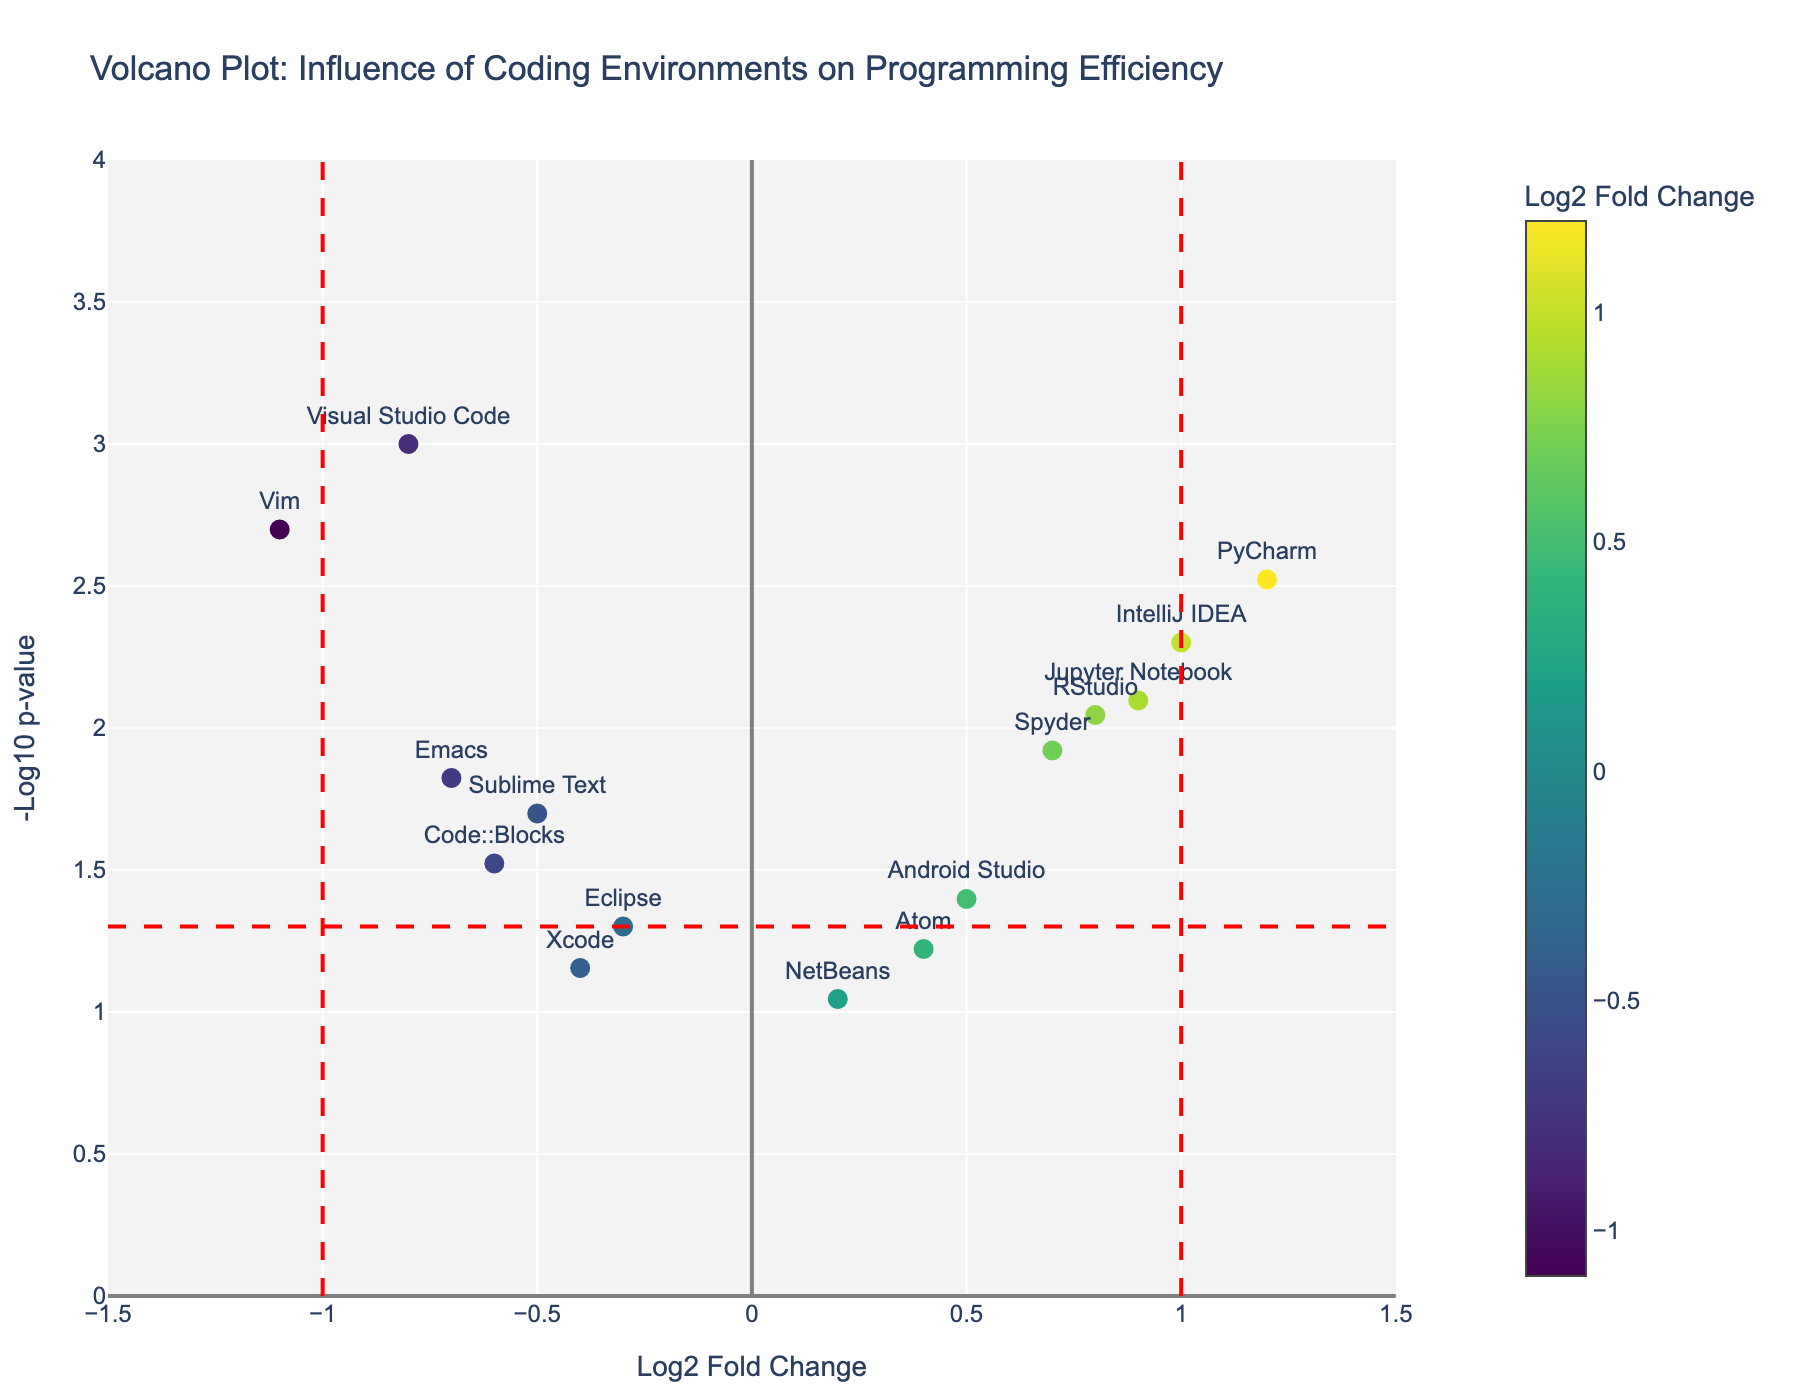What is the title of the plot? The title of the plot is displayed prominently at the top of the figure in larger font size.
Answer: Volcano Plot: Influence of Coding Environments on Programming Efficiency How many coding environments are plotted in the figure? Count the number of distinct markers representing different coding environments in the scatter plot.
Answer: 15 What is the x-axis representing? The x-axis is labeled at the bottom of the figure, indicating that it represents the Log2 Fold Change.
Answer: Log2 Fold Change Which coding environment has the highest fold change and how significant is it? Look for the coding environment with the highest position on the y-axis and its label. IntelliJ IDEA has a Log2 fold change of 1.0 and a p-value of 0.005, indicated by its height on the -log10(p-value) axis.
Answer: IntelliJ IDEA, very significant Which coding environments significantly decrease programming efficiency? Check for markers left of the vertical line at x=-1 and above the horizontal dash line, indicating significant negative fold changes. Visual Studio Code and Vim fall in this region.
Answer: Visual Studio Code, Vim What is the fold change threshold for determining significance? The red vertical lines at x=-1 and x=1 indicate the threshold for significant fold changes.
Answer: 1.0 Which coding environments have log2 fold changes between -0.5 and 0.5 but are not statistically significant? Identify markers with fold changes in the range -0.5 to 0.5 and below the horizontal line representing the p-value threshold. NetBeans usually falls in this category.
Answer: NetBeans How many coding environments show a positive effect on programming efficiency and are statistically significant? Count the number of coding environments with positive log2 fold changes (right of x=1) and above the horizontal line. PyCharm, Jupyter Notebook, IntelliJ IDEA, and RStudio fall into this category.
Answer: 4 Which coding environment has a log2 fold change closest to 0 and is it statistically significant? Find the marker closest to x=0 and check its p-value with the horizontal line reference. NetBeans has a log2 fold change closest to 0 and is not statistically significant.
Answer: NetBeans, not significant 